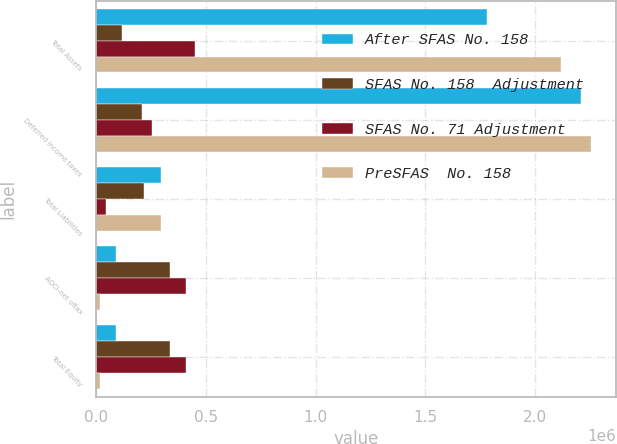Convert chart. <chart><loc_0><loc_0><loc_500><loc_500><stacked_bar_chart><ecel><fcel>Total Assets<fcel>Deferred income taxes<fcel>Total Liabilities<fcel>AOCI-net oftax<fcel>Total Equity<nl><fcel>After SFAS No. 158<fcel>1.7819e+06<fcel>2.21125e+06<fcel>296382<fcel>89130<fcel>89130<nl><fcel>SFAS No. 158  Adjustment<fcel>117023<fcel>211061<fcel>219330<fcel>336353<fcel>336353<nl><fcel>SFAS No. 71 Adjustment<fcel>452472<fcel>256410<fcel>43315<fcel>409157<fcel>409157<nl><fcel>PreSFAS  No. 158<fcel>2.11735e+06<fcel>2.2566e+06<fcel>296382<fcel>16326<fcel>16326<nl></chart> 